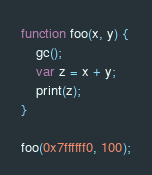Convert code to text. <code><loc_0><loc_0><loc_500><loc_500><_JavaScript_>
function foo(x, y) {
    gc();
    var z = x + y;
    print(z);
}

foo(0x7ffffff0, 100);
</code> 